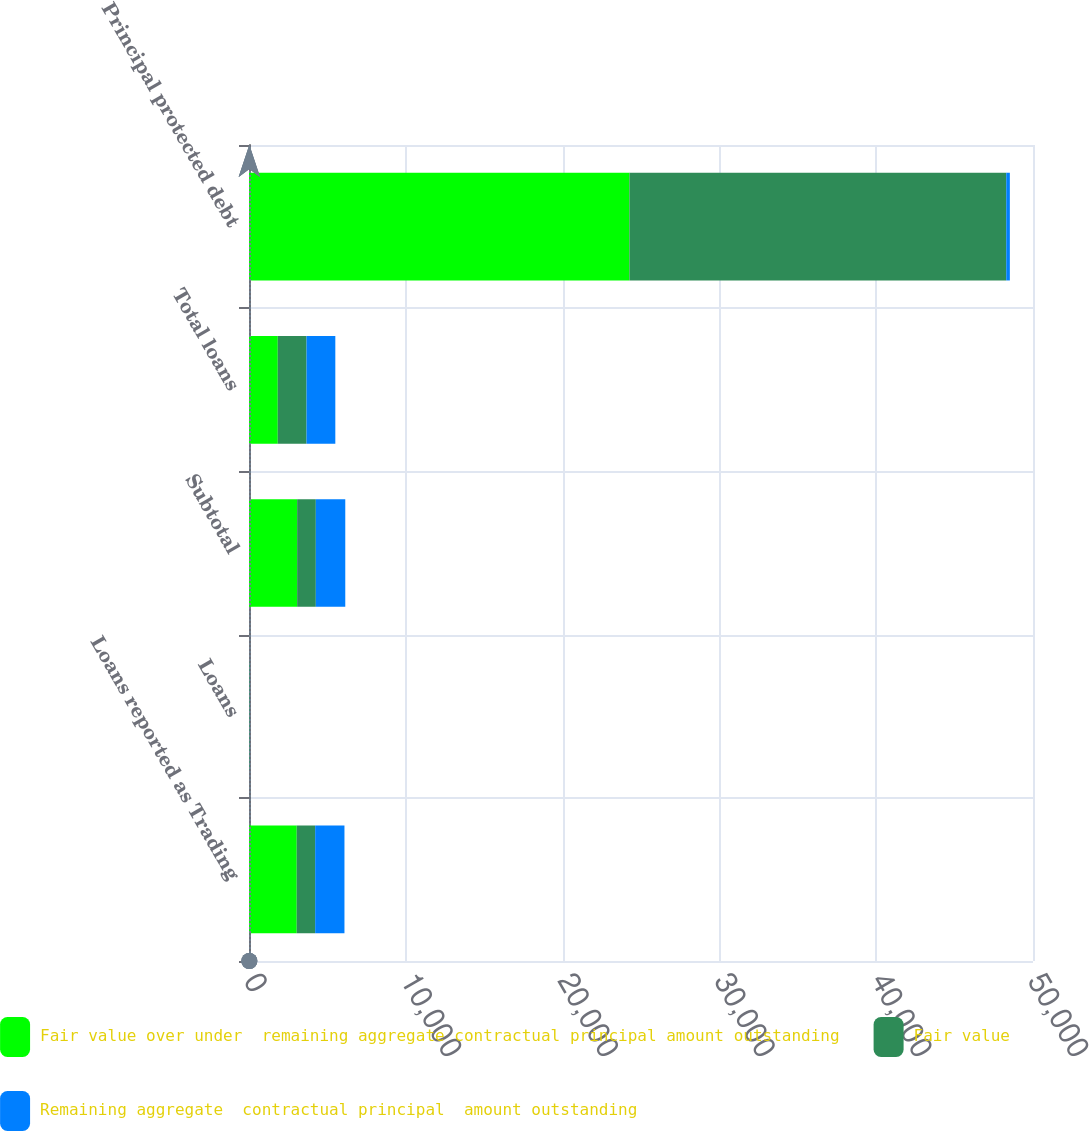Convert chart to OTSL. <chart><loc_0><loc_0><loc_500><loc_500><stacked_bar_chart><ecel><fcel>Loans reported as Trading<fcel>Loans<fcel>Subtotal<fcel>Total loans<fcel>Principal protected debt<nl><fcel>Fair value over under  remaining aggregate contractual principal amount outstanding<fcel>3044<fcel>15<fcel>3070<fcel>1835<fcel>24262<nl><fcel>Fair value<fcel>1176<fcel>5<fcel>1192<fcel>1835<fcel>24033<nl><fcel>Remaining aggregate  contractual principal  amount outstanding<fcel>1868<fcel>10<fcel>1878<fcel>1835<fcel>229<nl></chart> 